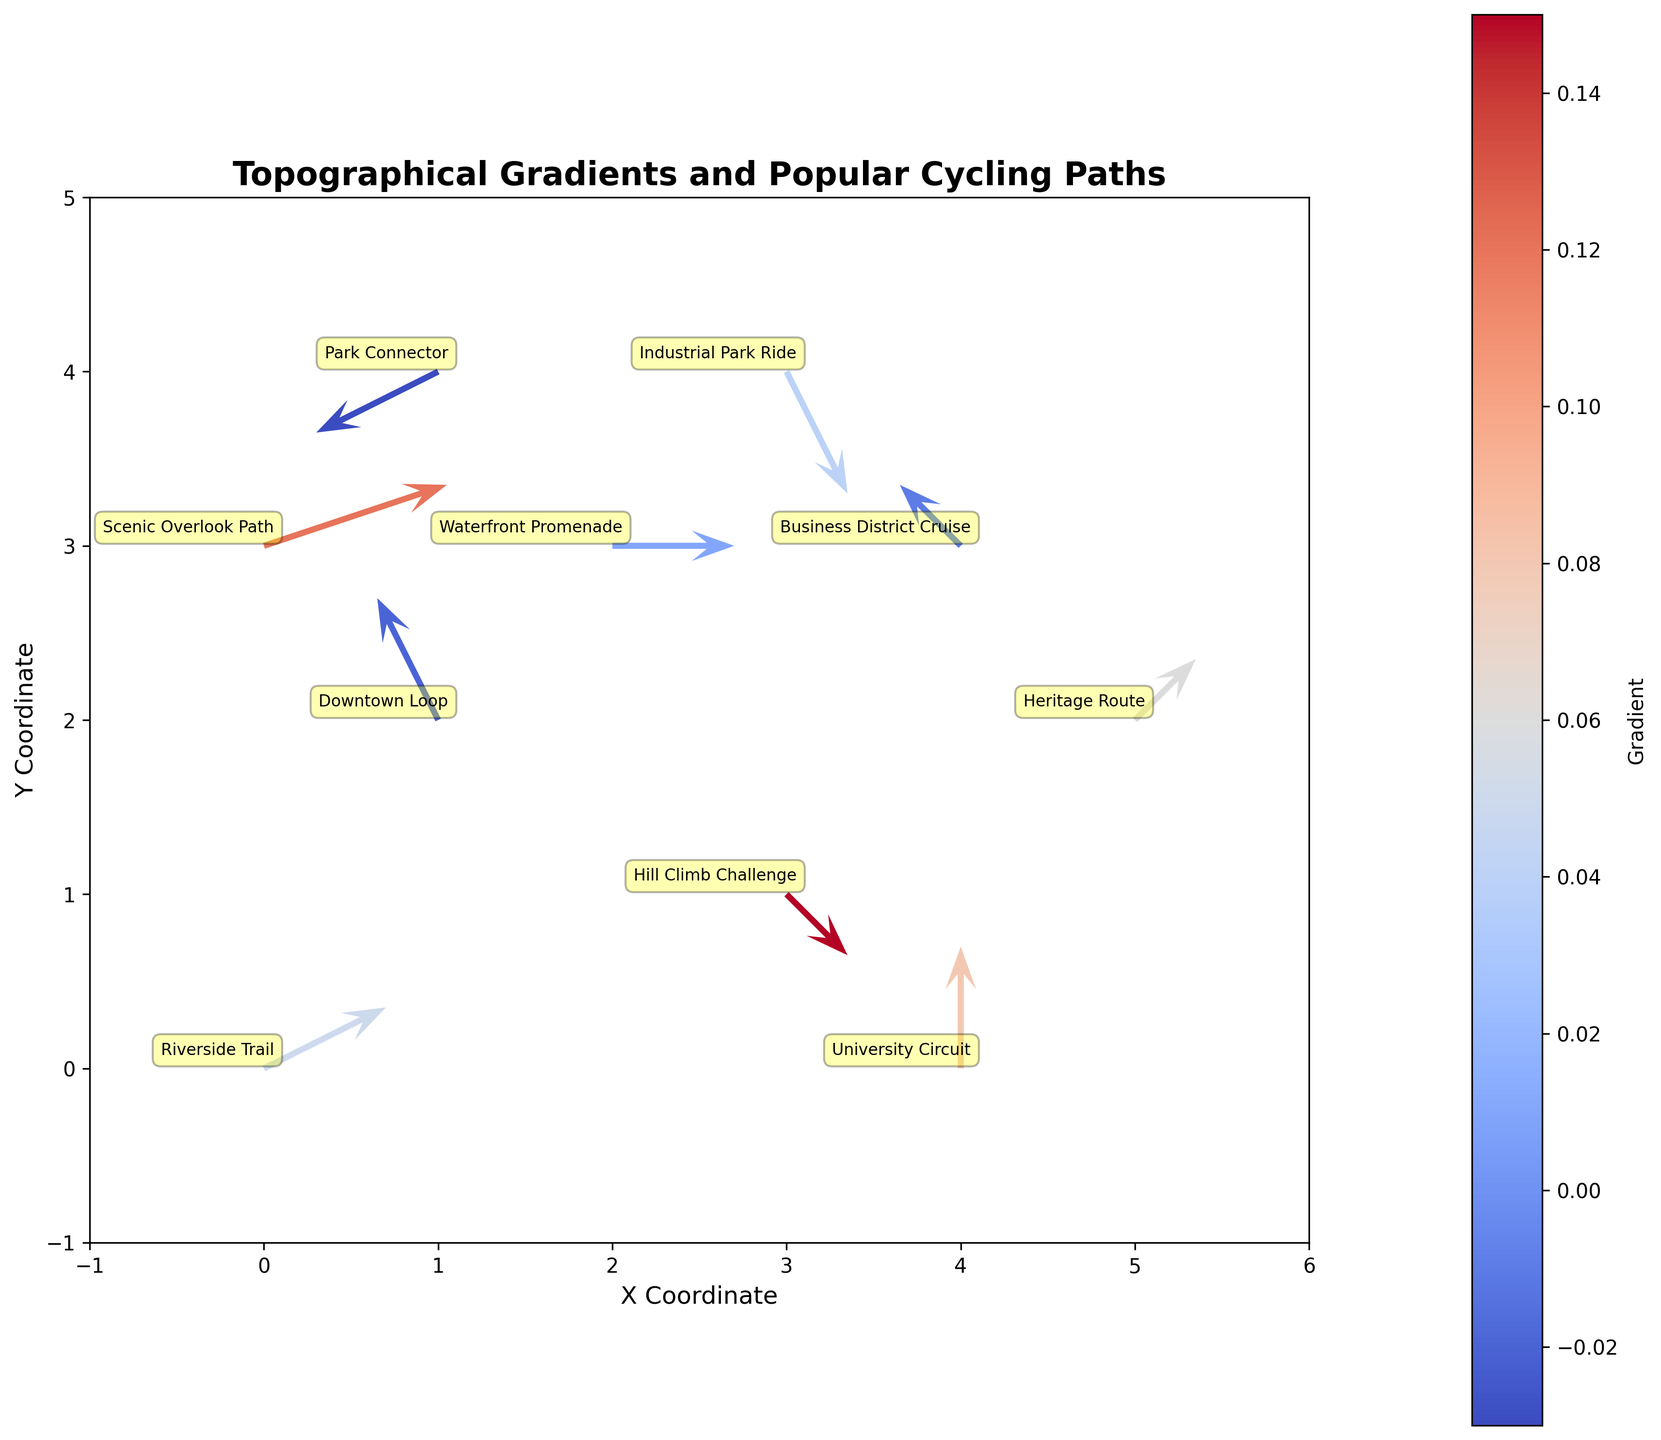What's the title of the figure? The title of the figure is usually located at the top, clearly stating what the plot is about. In this case, it reads "Topographical Gradients and Popular Cycling Paths".
Answer: Topographical Gradients and Popular Cycling Paths How many data points (paths) are plotted in the figure? Count the number of arrows or annotations corresponding to each path name. There are 10 paths listed, each with its own arrow.
Answer: 10 Which path has the highest gradient? By examining the color bar and the arrows, the path with the arrow showing the highest gradient, which is the darkest red, corresponds to the labeled "Hill Climb Challenge".
Answer: Hill Climb Challenge Which path has a negative gradient and is plotted close to the origin? By looking at arrows near the origin (0,0) and checking those with negative colors (using the color bar), the path "Downtown Loop" fits this description.
Answer: Downtown Loop How many paths extend in the negative x-direction? Look for arrows where the dx component is negative. From the figure, the paths "Downtown Loop", "Park Connector", and "Business District Cruise" extend in the negative x-direction.
Answer: 3 Which path has the steepest gradient in the negative direction? Find the path with the most negative gradient value by cross-referencing with the color bar. The "Downtown Loop" has the most negative gradient.
Answer: Downtown Loop Compare the gradients of the "Riverside Trail" and the "Scenic Overlook Path". Which one is higher? Look at the color coding for each respective path. "Riverside Trail" is light red, while "Scenic Overlook Path" is darker red. Darker red indicates a higher positive gradient.
Answer: Scenic Overlook Path What is the average gradient of all paths? Sum all the gradients and divide by the number of paths. (0.05 + (-0.02) + 0.15 + 0.01 + 0.08 + (-0.03) + 0.06 + 0.04 + 0.12 + (-0.01)) / 10 = 0.045
Answer: 0.045 Which path starts at the highest y-coordinate? Look for the highest y starting position. The "Park Connector" starts at y = 4.
Answer: Park Connector Identify the path that starts at the coordinate (4,3) and describe its movement direction. Find the path whose starting coordinates are (4,3). The "Business District Cruise" starts at (4,3) and moves to (3,4), giving it a direction of roughly southwest.
Answer: Business District Cruise, southwest 